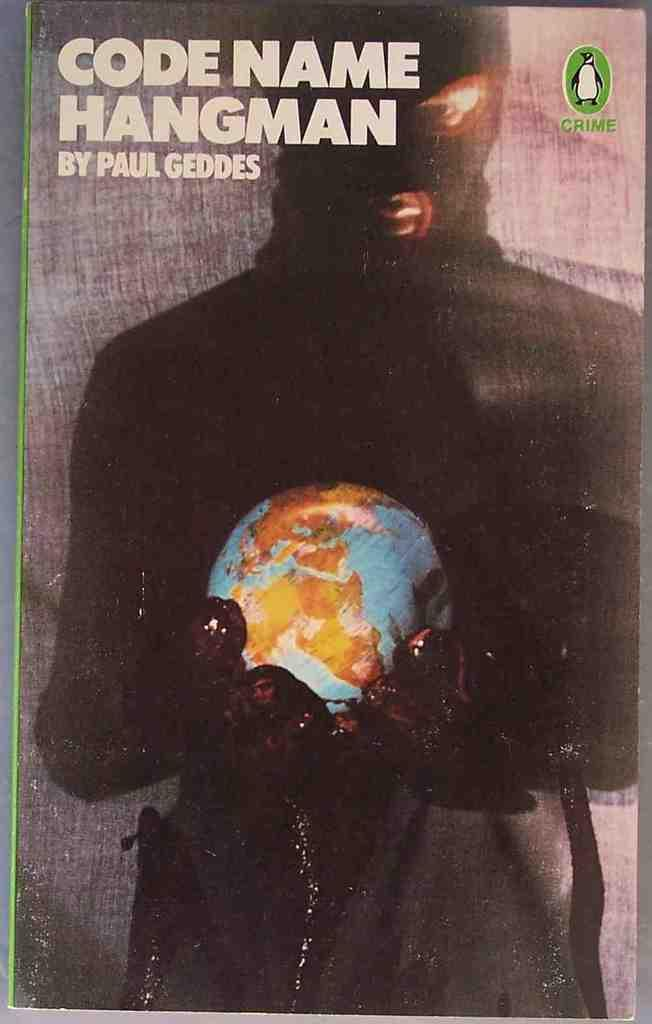<image>
Offer a succinct explanation of the picture presented. the word code is on the front of the book 